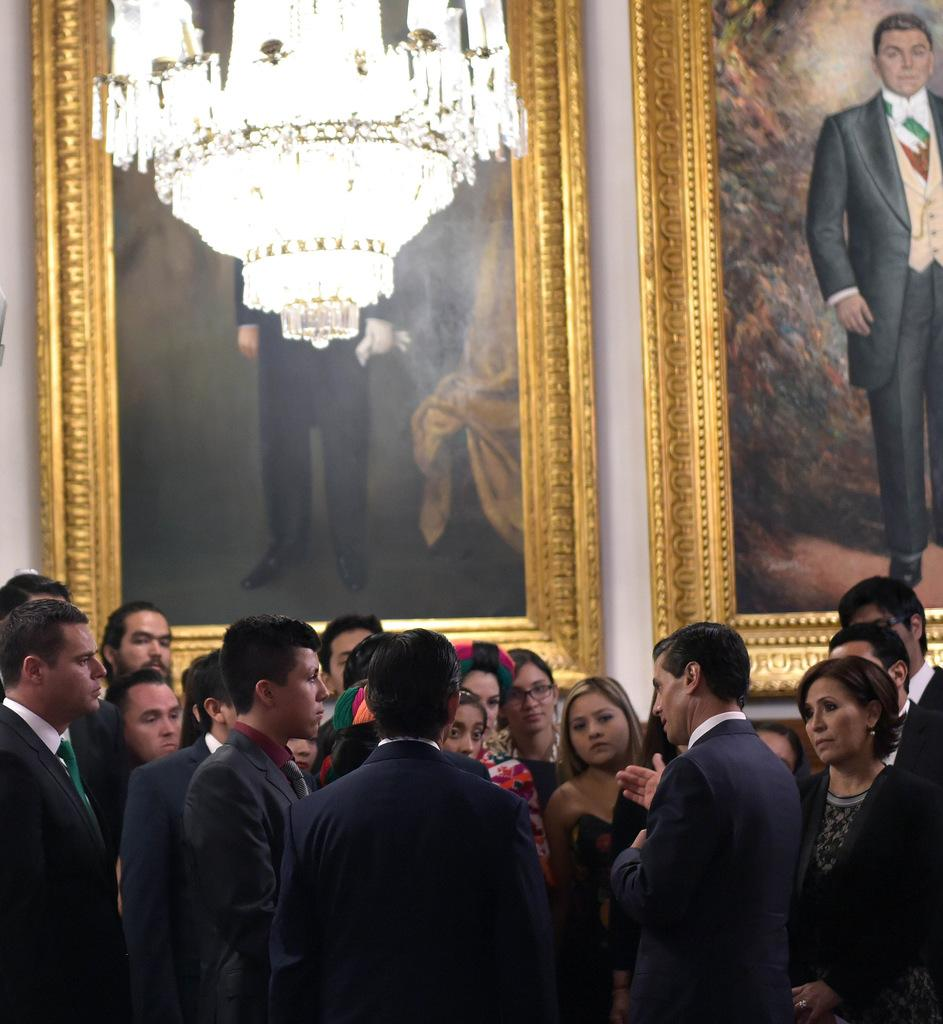What can be seen in the image involving people? There are people standing in the image. What is present on the wall in the background? There are frames placed on the wall in the background. Can you describe the lighting in the image? There is a light at the top of the image. What type of list can be seen hanging from the ceiling in the image? There is no list present in the image; it only features people standing, frames on the wall, and a light at the top. 